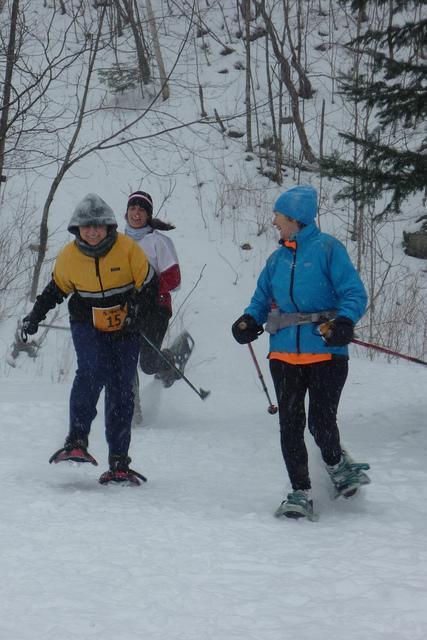How many people are there?
Give a very brief answer. 3. How many people can you see?
Give a very brief answer. 3. How many horses are there?
Give a very brief answer. 0. 